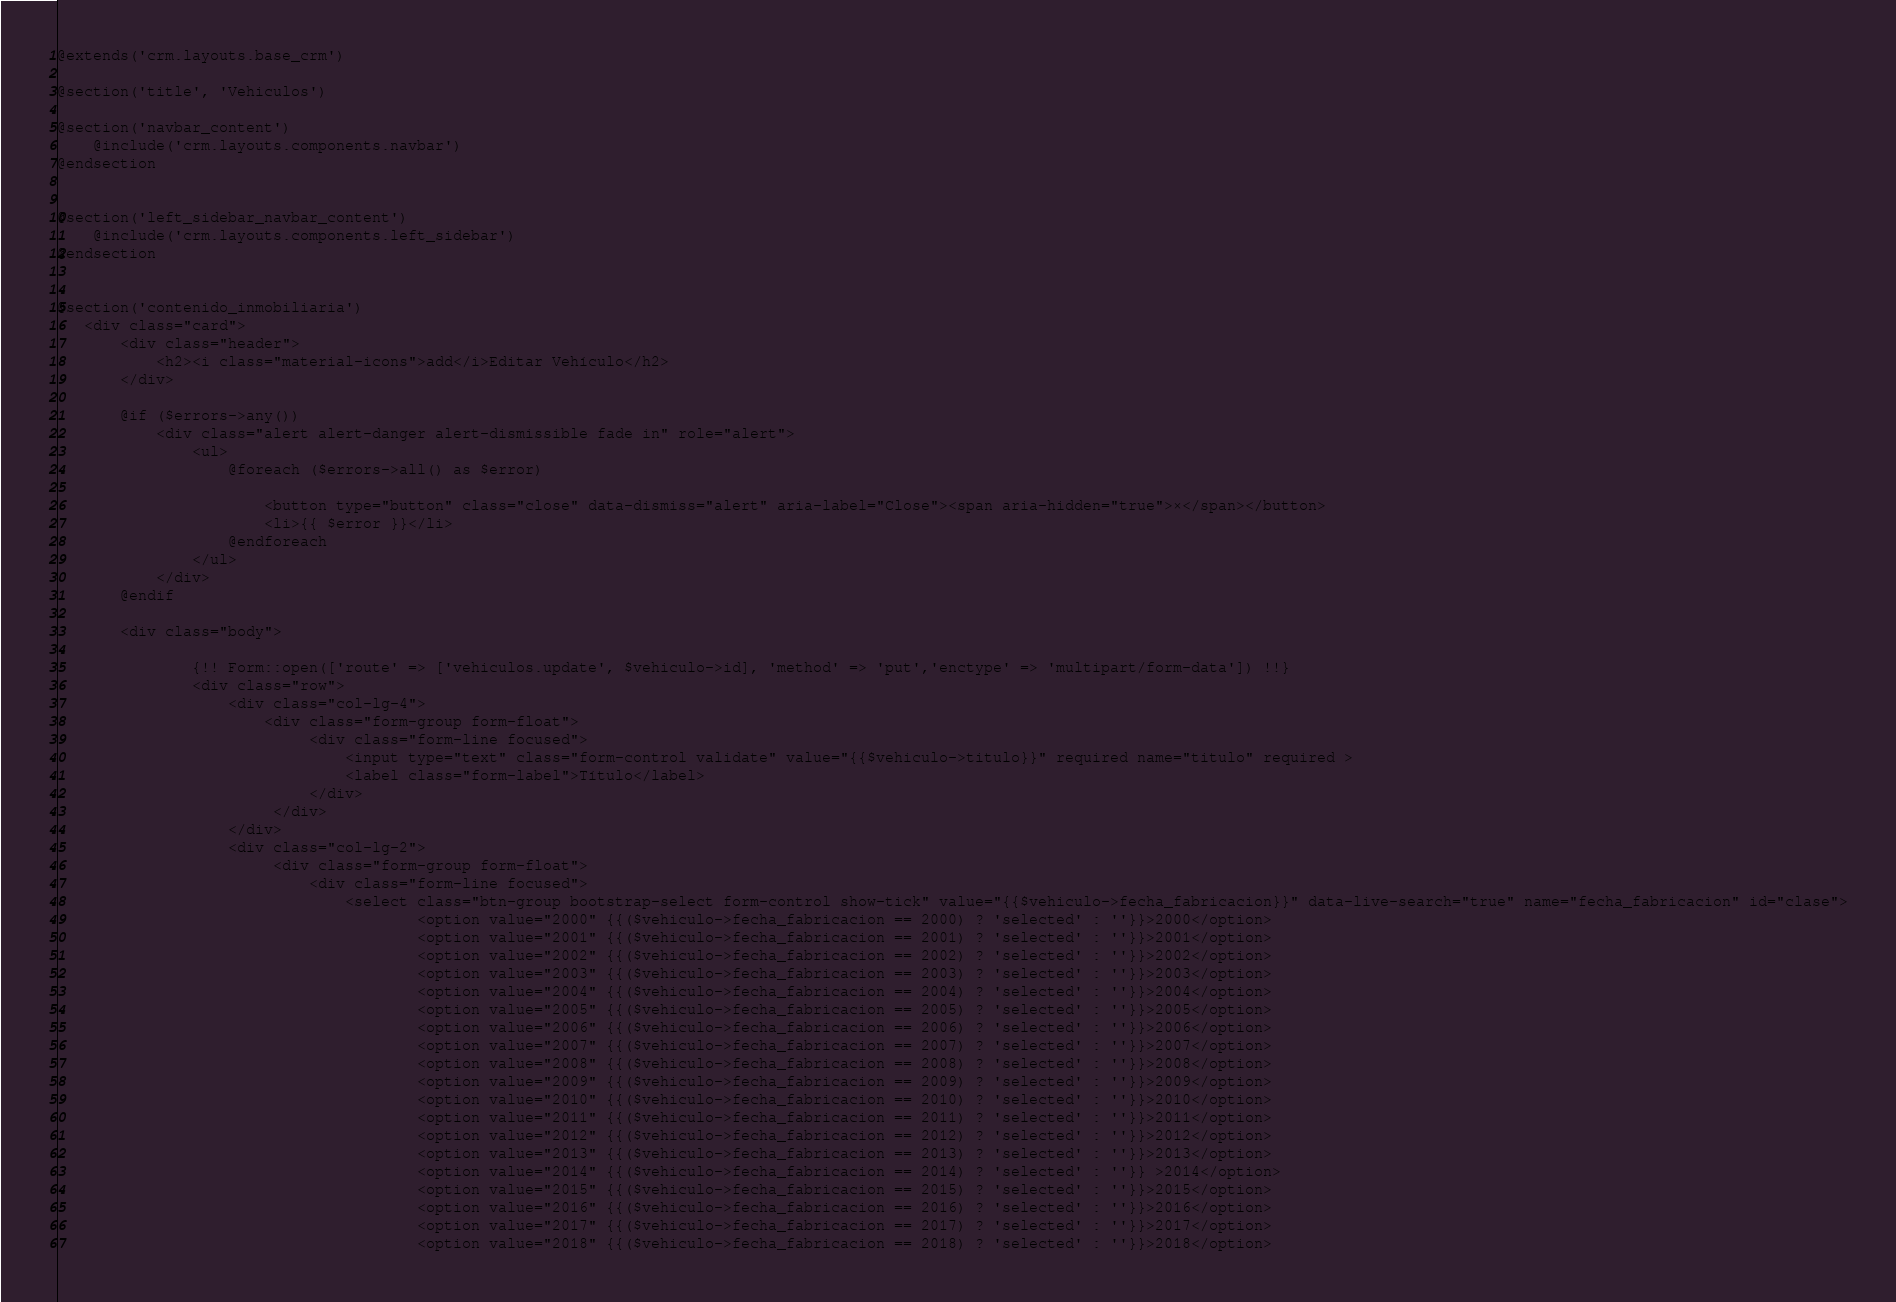Convert code to text. <code><loc_0><loc_0><loc_500><loc_500><_PHP_>@extends('crm.layouts.base_crm')

@section('title', 'Vehiculos')

@section('navbar_content')
    @include('crm.layouts.components.navbar')
@endsection


@section('left_sidebar_navbar_content')
    @include('crm.layouts.components.left_sidebar')
@endsection


@section('contenido_inmobiliaria')
   <div class="card">
       <div class="header">
           <h2><i class="material-icons">add</i>Editar Vehículo</h2>
       </div>

       @if ($errors->any())
           <div class="alert alert-danger alert-dismissible fade in" role="alert">
               <ul>
                   @foreach ($errors->all() as $error)

                       <button type="button" class="close" data-dismiss="alert" aria-label="Close"><span aria-hidden="true">×</span></button>
                       <li>{{ $error }}</li>
                   @endforeach
               </ul>
           </div>
       @endif

       <div class="body">

               {!! Form::open(['route' => ['vehiculos.update', $vehiculo->id], 'method' => 'put','enctype' => 'multipart/form-data']) !!}
               <div class="row">
                   <div class="col-lg-4">
                       <div class="form-group form-float">
                            <div class="form-line focused">
                                <input type="text" class="form-control validate" value="{{$vehiculo->titulo}}" required name="titulo" required >
                                <label class="form-label">Título</label>
                            </div>
                        </div>
                   </div>
                   <div class="col-lg-2">
                        <div class="form-group form-float">
                            <div class="form-line focused">
                                <select class="btn-group bootstrap-select form-control show-tick" value="{{$vehiculo->fecha_fabricacion}}" data-live-search="true" name="fecha_fabricacion" id="clase">
                                        <option value="2000" {{($vehiculo->fecha_fabricacion == 2000) ? 'selected' : ''}}>2000</option>
                                        <option value="2001" {{($vehiculo->fecha_fabricacion == 2001) ? 'selected' : ''}}>2001</option>
                                        <option value="2002" {{($vehiculo->fecha_fabricacion == 2002) ? 'selected' : ''}}>2002</option>
                                        <option value="2003" {{($vehiculo->fecha_fabricacion == 2003) ? 'selected' : ''}}>2003</option>
                                        <option value="2004" {{($vehiculo->fecha_fabricacion == 2004) ? 'selected' : ''}}>2004</option>
                                        <option value="2005" {{($vehiculo->fecha_fabricacion == 2005) ? 'selected' : ''}}>2005</option>
                                        <option value="2006" {{($vehiculo->fecha_fabricacion == 2006) ? 'selected' : ''}}>2006</option>
                                        <option value="2007" {{($vehiculo->fecha_fabricacion == 2007) ? 'selected' : ''}}>2007</option>
                                        <option value="2008" {{($vehiculo->fecha_fabricacion == 2008) ? 'selected' : ''}}>2008</option>
                                        <option value="2009" {{($vehiculo->fecha_fabricacion == 2009) ? 'selected' : ''}}>2009</option>
                                        <option value="2010" {{($vehiculo->fecha_fabricacion == 2010) ? 'selected' : ''}}>2010</option>
                                        <option value="2011" {{($vehiculo->fecha_fabricacion == 2011) ? 'selected' : ''}}>2011</option>
                                        <option value="2012" {{($vehiculo->fecha_fabricacion == 2012) ? 'selected' : ''}}>2012</option>
                                        <option value="2013" {{($vehiculo->fecha_fabricacion == 2013) ? 'selected' : ''}}>2013</option>
                                        <option value="2014" {{($vehiculo->fecha_fabricacion == 2014) ? 'selected' : ''}} >2014</option>
                                        <option value="2015" {{($vehiculo->fecha_fabricacion == 2015) ? 'selected' : ''}}>2015</option>
                                        <option value="2016" {{($vehiculo->fecha_fabricacion == 2016) ? 'selected' : ''}}>2016</option>
                                        <option value="2017" {{($vehiculo->fecha_fabricacion == 2017) ? 'selected' : ''}}>2017</option>
                                        <option value="2018" {{($vehiculo->fecha_fabricacion == 2018) ? 'selected' : ''}}>2018</option></code> 